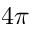Convert formula to latex. <formula><loc_0><loc_0><loc_500><loc_500>4 \pi</formula> 